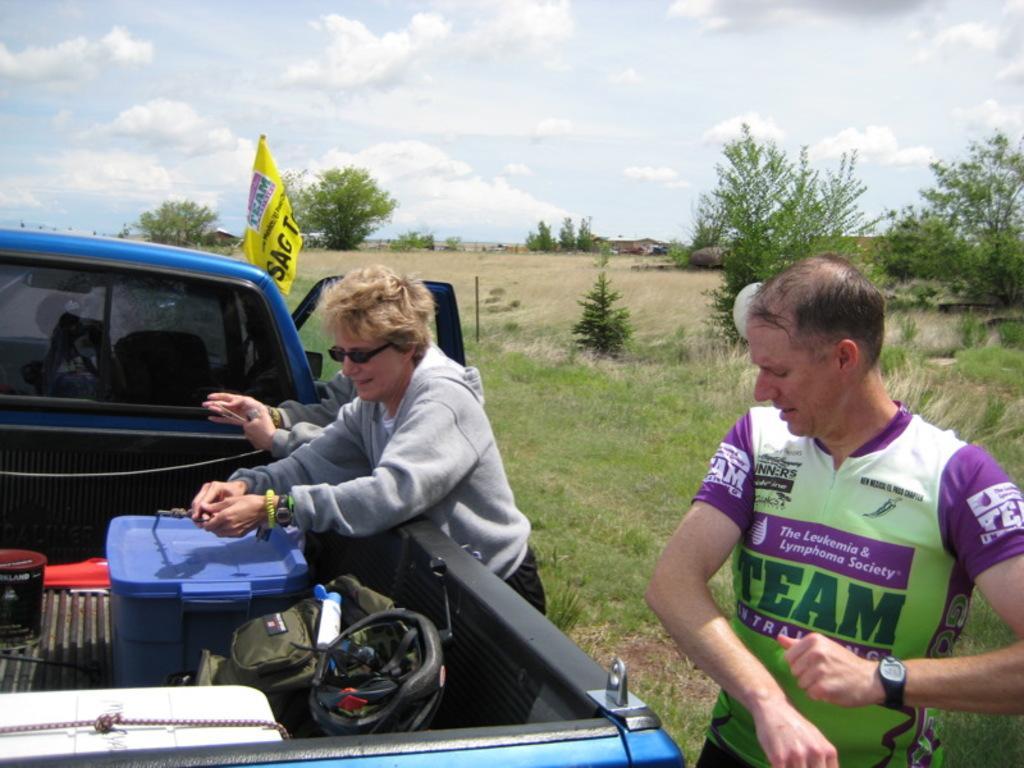Describe this image in one or two sentences. In this picture I can see three persons standing, there are some objects on the truck, this is looking like a flag, there are trees, and in the background there is sky. 